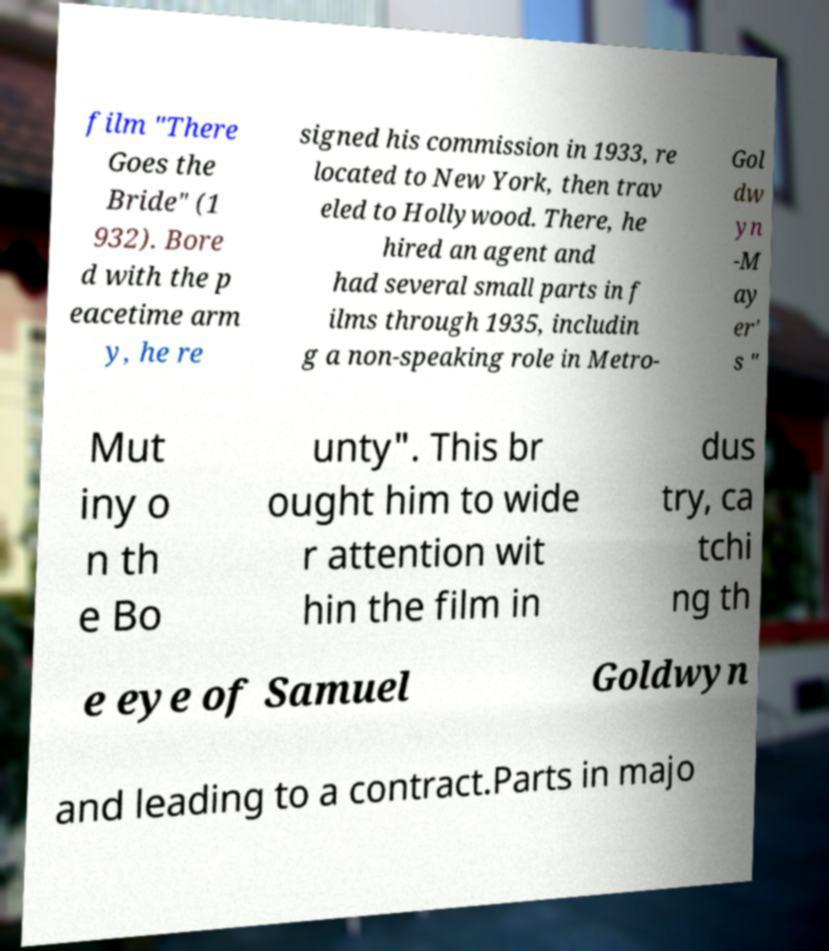Can you accurately transcribe the text from the provided image for me? film "There Goes the Bride" (1 932). Bore d with the p eacetime arm y, he re signed his commission in 1933, re located to New York, then trav eled to Hollywood. There, he hired an agent and had several small parts in f ilms through 1935, includin g a non-speaking role in Metro- Gol dw yn -M ay er' s " Mut iny o n th e Bo unty". This br ought him to wide r attention wit hin the film in dus try, ca tchi ng th e eye of Samuel Goldwyn and leading to a contract.Parts in majo 